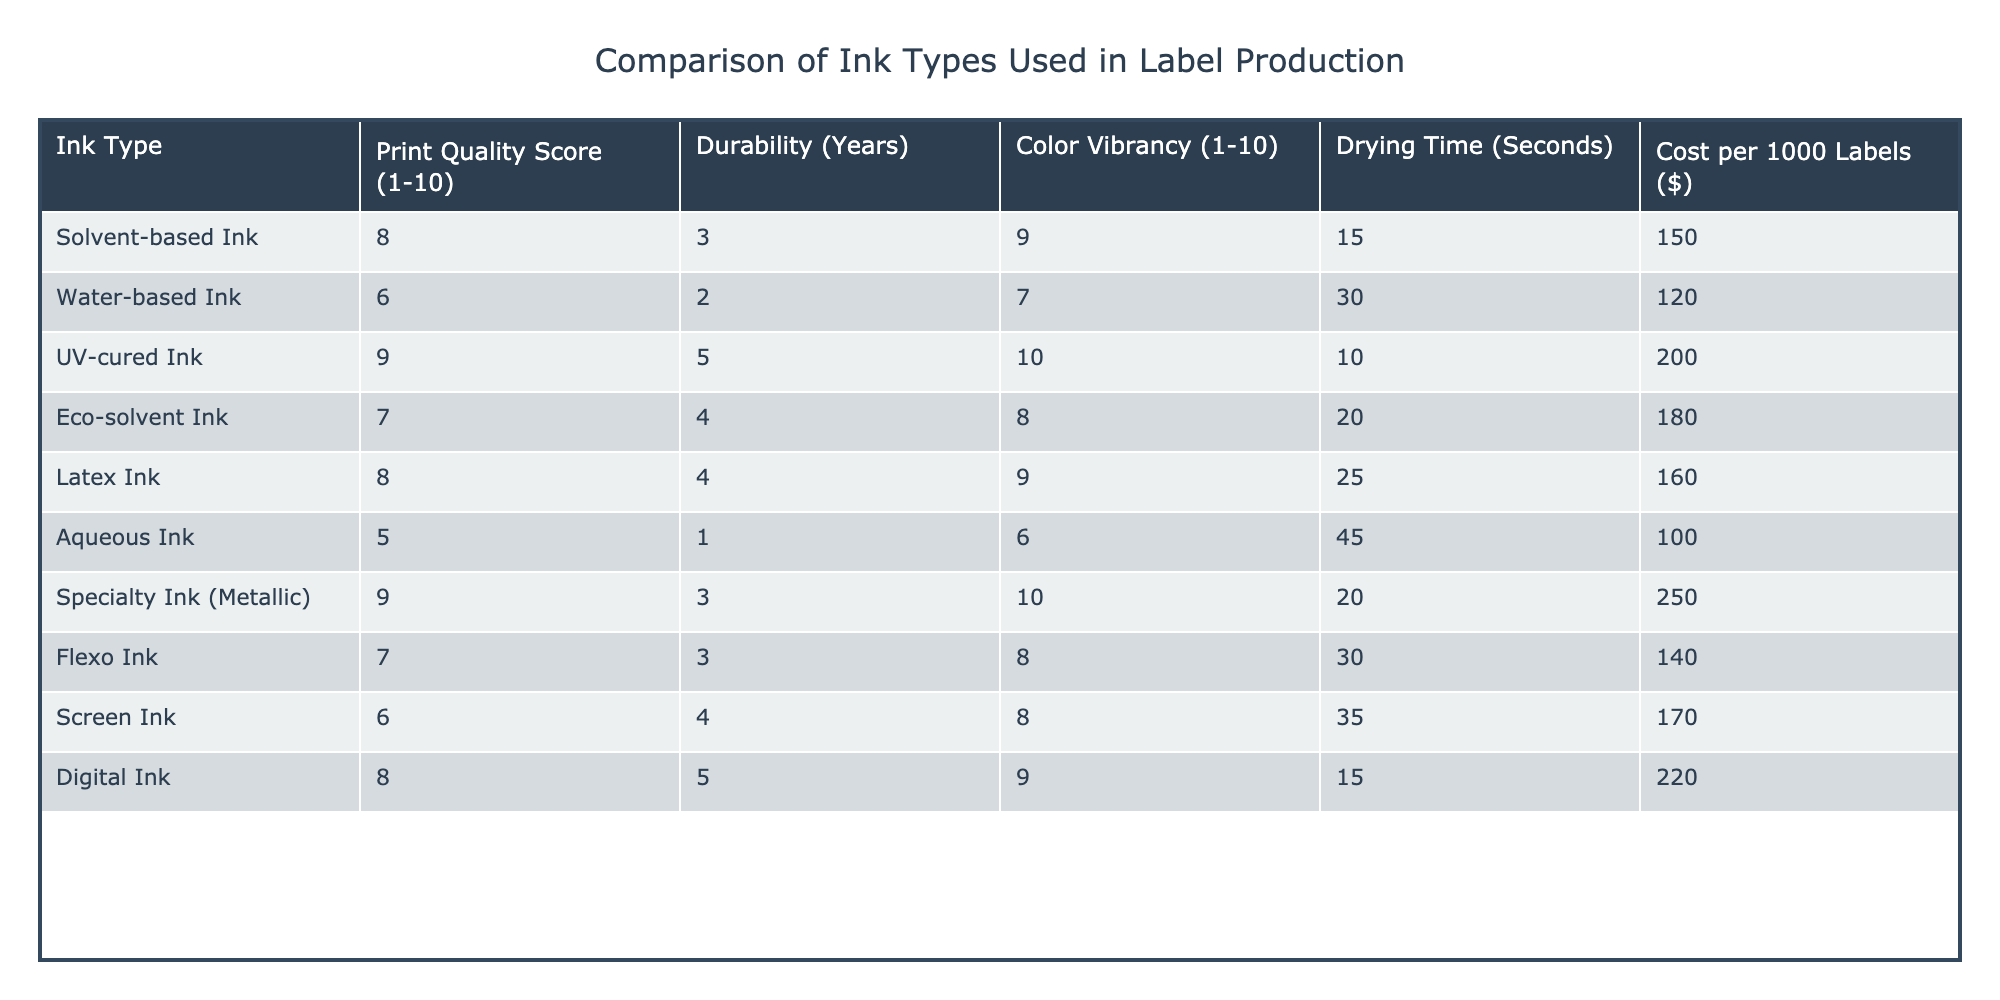What is the print quality score of UV-cured ink? The table shows that the print quality score for UV-cured ink is 9. This can be found directly under the corresponding column for UV-cured ink.
Answer: 9 Which ink type has the highest color vibrancy? The color vibrancy column indicates that both UV-cured ink and specialty ink (metallic) have the highest score of 10. By comparing the values in this column, we see these two inks are tied for first place.
Answer: UV-cured ink and specialty ink (metallic) What is the average durability of all ink types listed? To find the average durability, we sum the durability scores (3 + 2 + 5 + 4 + 4 + 1 + 3 + 3 + 4 + 5) = 36. There are 10 ink types, so the average durability is 36/10 = 3.6 years.
Answer: 3.6 years Is the drying time of water-based ink less than that of aqueous ink? The drying time for water-based ink is 30 seconds, while for aqueous ink it is 45 seconds. Since 30 is less than 45, the statement is true.
Answer: Yes Which ink offers the best balance of print quality and cost? To evaluate this, we look for the highest print quality score relative to cost per 1000 labels. Considering the scores and costs, UV-cured ink has a score of 9 but costs $200, while digital ink has a score of 8 and costs $220. Evaluating the cost-effectiveness by dividing print quality score by cost gives us UV-cured ink (9/200 = 0.045) and digital ink (8/220 = 0.036). Therefore, UV-cured ink offers the best balance of quality and cost.
Answer: UV-cured ink How does the durability of eco-solvent ink compare to that of solvent-based ink? Eco-solvent ink has a durability of 4 years, whereas solvent-based ink has a durability of 3 years. Comparing these values shows that eco-solvent ink lasts longer than solvent-based ink.
Answer: Eco-solvent ink lasts longer What is the total cost to print 5000 labels using specialty ink (metallic)? The cost per 1000 labels for specialty ink (metallic) is $250. For 5000 labels, we multiply this cost by 5 (250 * 5 = 1250). Therefore, the total cost to print 5000 labels is $1250.
Answer: 1250 Which ink type has the best combination of durability and print quality score? To find this, we compare the combinations of durability and print quality scores for each ink. UV-cured ink has a print quality score of 9 and durability of 5 years. When we look for the best combination of both these factors, UV-cured ink stands out as it has the highest print quality score and solid durability.
Answer: UV-cured ink Are all ink types rated equally for print quality? No, the print quality scores are varying, with values ranging from 5 for aqueous ink to 9 for UV-cured ink and specialty ink, indicating that not all ink types have the same quality rating.
Answer: No 